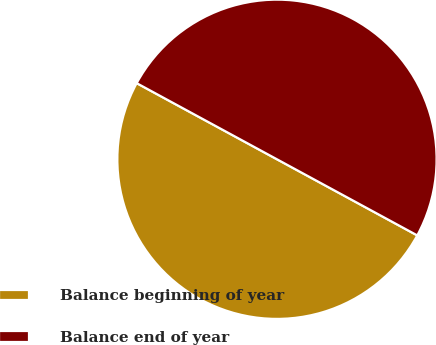Convert chart to OTSL. <chart><loc_0><loc_0><loc_500><loc_500><pie_chart><fcel>Balance beginning of year<fcel>Balance end of year<nl><fcel>50.0%<fcel>50.0%<nl></chart> 